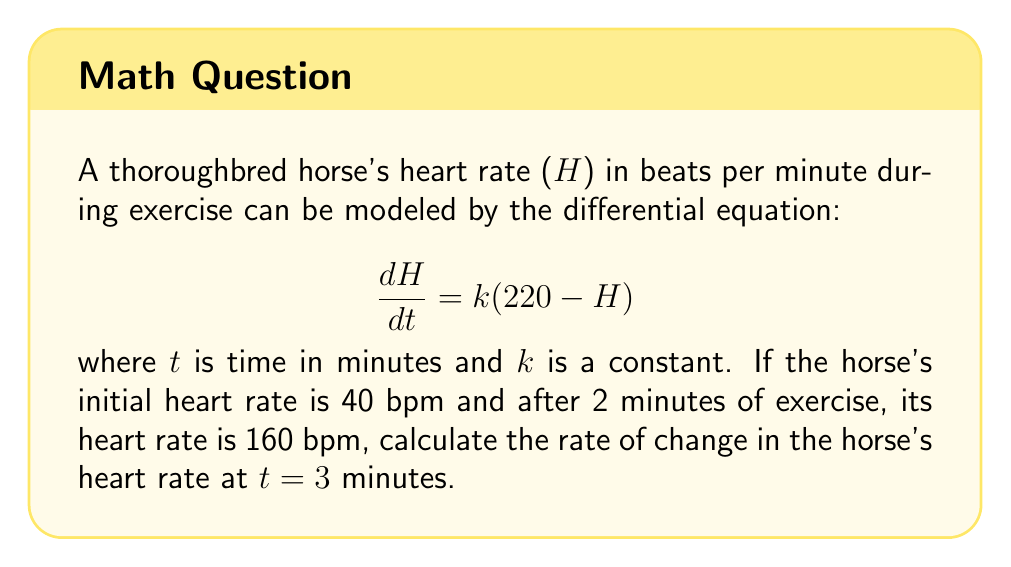Solve this math problem. 1) First, we need to solve for k using the given information:
   Initial condition: H(0) = 40
   After 2 minutes: H(2) = 160

2) The general solution to the differential equation is:
   $$H(t) = 220 - (220 - H_0)e^{-kt}$$
   where H_0 is the initial heart rate.

3) Substituting the known values:
   $$160 = 220 - (220 - 40)e^{-2k}$$
   $$60 = 180e^{-2k}$$
   $$\frac{1}{3} = e^{-2k}$$

4) Taking natural log of both sides:
   $$\ln(\frac{1}{3}) = -2k$$
   $$k = \frac{\ln(3)}{2} \approx 0.5493$$

5) Now that we have k, we can find H(3) using the general solution:
   $$H(3) = 220 - (220 - 40)e^{-0.5493 \cdot 3} \approx 185.4$$

6) To find the rate of change at t = 3, we use the original differential equation:
   $$\frac{dH}{dt} = k(220 - H)$$

7) Substituting the values:
   $$\frac{dH}{dt} = 0.5493(220 - 185.4) \approx 19.0$$
Answer: 19.0 bpm/min 